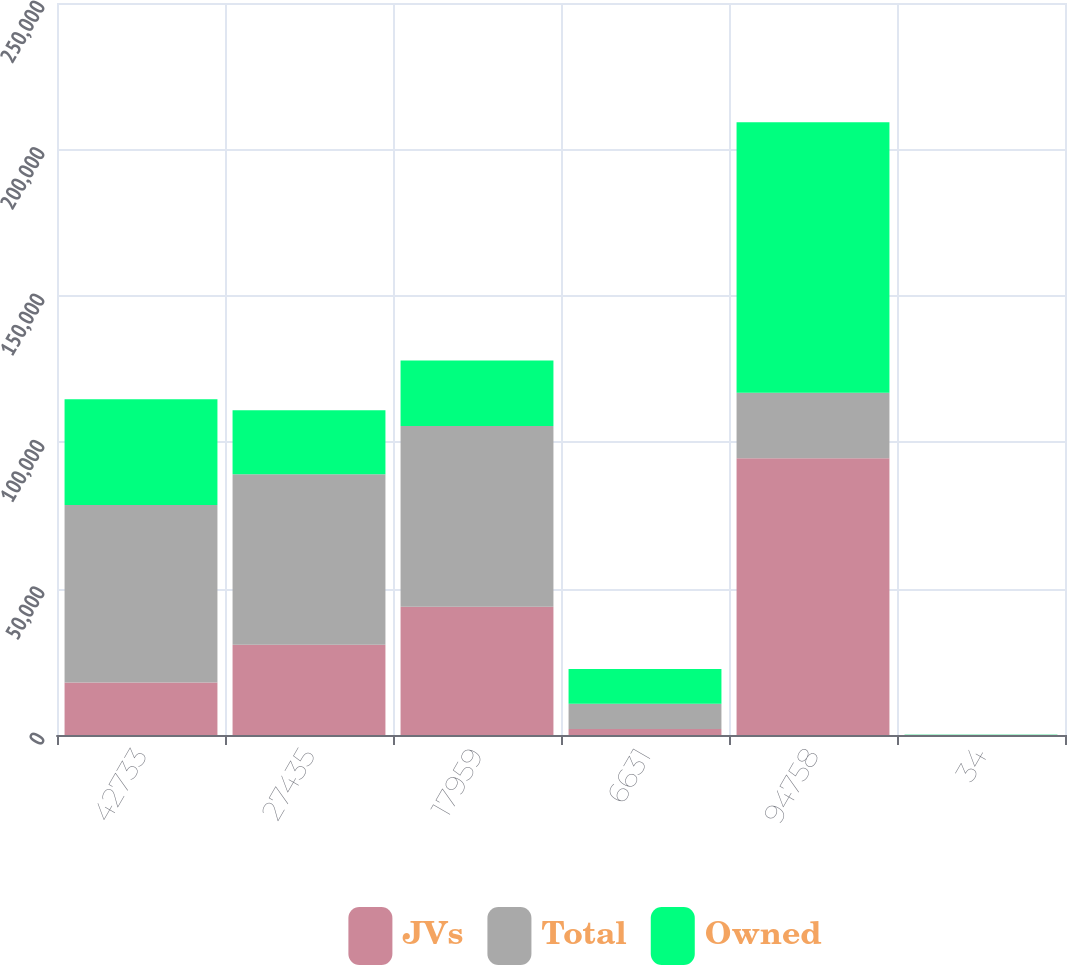Convert chart. <chart><loc_0><loc_0><loc_500><loc_500><stacked_bar_chart><ecel><fcel>42733<fcel>27435<fcel>17959<fcel>6631<fcel>94758<fcel>34<nl><fcel>JVs<fcel>17898<fcel>30815<fcel>43789<fcel>2019<fcel>94521<fcel>33<nl><fcel>Total<fcel>60631<fcel>58250<fcel>61748<fcel>8650<fcel>22390<fcel>67<nl><fcel>Owned<fcel>36169<fcel>21887<fcel>22390<fcel>11879<fcel>92325<fcel>33<nl></chart> 